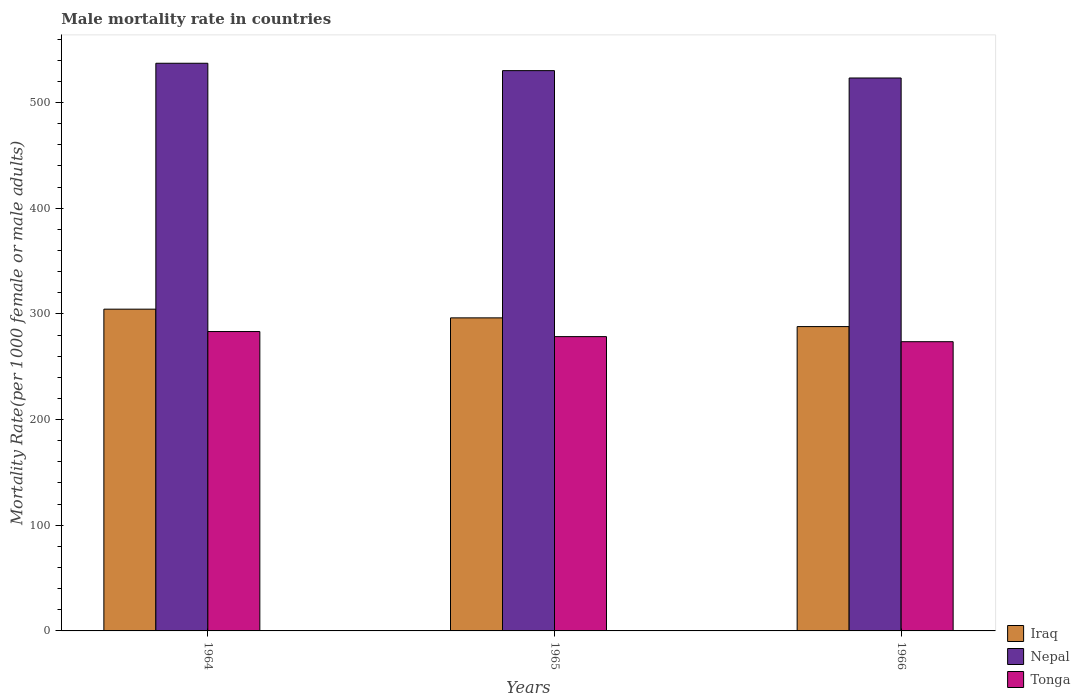How many bars are there on the 3rd tick from the left?
Make the answer very short. 3. What is the label of the 3rd group of bars from the left?
Keep it short and to the point. 1966. In how many cases, is the number of bars for a given year not equal to the number of legend labels?
Your answer should be very brief. 0. What is the male mortality rate in Tonga in 1964?
Offer a very short reply. 283.32. Across all years, what is the maximum male mortality rate in Nepal?
Offer a very short reply. 537.21. Across all years, what is the minimum male mortality rate in Nepal?
Offer a very short reply. 523.26. In which year was the male mortality rate in Tonga maximum?
Make the answer very short. 1964. In which year was the male mortality rate in Tonga minimum?
Make the answer very short. 1966. What is the total male mortality rate in Tonga in the graph?
Your answer should be very brief. 835.54. What is the difference between the male mortality rate in Nepal in 1965 and that in 1966?
Your response must be concise. 6.97. What is the difference between the male mortality rate in Iraq in 1965 and the male mortality rate in Nepal in 1964?
Offer a terse response. -240.95. What is the average male mortality rate in Tonga per year?
Make the answer very short. 278.51. In the year 1964, what is the difference between the male mortality rate in Nepal and male mortality rate in Iraq?
Provide a short and direct response. 232.71. In how many years, is the male mortality rate in Nepal greater than 20?
Provide a succinct answer. 3. What is the ratio of the male mortality rate in Tonga in 1965 to that in 1966?
Provide a succinct answer. 1.02. Is the male mortality rate in Nepal in 1964 less than that in 1965?
Make the answer very short. No. Is the difference between the male mortality rate in Nepal in 1964 and 1966 greater than the difference between the male mortality rate in Iraq in 1964 and 1966?
Provide a short and direct response. No. What is the difference between the highest and the second highest male mortality rate in Nepal?
Your response must be concise. 6.97. What is the difference between the highest and the lowest male mortality rate in Nepal?
Offer a terse response. 13.94. In how many years, is the male mortality rate in Tonga greater than the average male mortality rate in Tonga taken over all years?
Provide a succinct answer. 1. Is the sum of the male mortality rate in Tonga in 1964 and 1966 greater than the maximum male mortality rate in Iraq across all years?
Offer a very short reply. Yes. What does the 3rd bar from the left in 1966 represents?
Make the answer very short. Tonga. What does the 2nd bar from the right in 1966 represents?
Your answer should be compact. Nepal. Are the values on the major ticks of Y-axis written in scientific E-notation?
Keep it short and to the point. No. Does the graph contain any zero values?
Ensure brevity in your answer.  No. Where does the legend appear in the graph?
Your response must be concise. Bottom right. How many legend labels are there?
Your answer should be compact. 3. What is the title of the graph?
Give a very brief answer. Male mortality rate in countries. Does "Kazakhstan" appear as one of the legend labels in the graph?
Keep it short and to the point. No. What is the label or title of the Y-axis?
Your answer should be compact. Mortality Rate(per 1000 female or male adults). What is the Mortality Rate(per 1000 female or male adults) in Iraq in 1964?
Provide a succinct answer. 304.5. What is the Mortality Rate(per 1000 female or male adults) in Nepal in 1964?
Offer a very short reply. 537.21. What is the Mortality Rate(per 1000 female or male adults) of Tonga in 1964?
Make the answer very short. 283.32. What is the Mortality Rate(per 1000 female or male adults) of Iraq in 1965?
Offer a terse response. 296.25. What is the Mortality Rate(per 1000 female or male adults) in Nepal in 1965?
Your response must be concise. 530.23. What is the Mortality Rate(per 1000 female or male adults) in Tonga in 1965?
Give a very brief answer. 278.51. What is the Mortality Rate(per 1000 female or male adults) of Iraq in 1966?
Provide a succinct answer. 288.01. What is the Mortality Rate(per 1000 female or male adults) of Nepal in 1966?
Provide a short and direct response. 523.26. What is the Mortality Rate(per 1000 female or male adults) of Tonga in 1966?
Make the answer very short. 273.71. Across all years, what is the maximum Mortality Rate(per 1000 female or male adults) in Iraq?
Offer a terse response. 304.5. Across all years, what is the maximum Mortality Rate(per 1000 female or male adults) in Nepal?
Your answer should be compact. 537.21. Across all years, what is the maximum Mortality Rate(per 1000 female or male adults) in Tonga?
Make the answer very short. 283.32. Across all years, what is the minimum Mortality Rate(per 1000 female or male adults) of Iraq?
Ensure brevity in your answer.  288.01. Across all years, what is the minimum Mortality Rate(per 1000 female or male adults) of Nepal?
Your response must be concise. 523.26. Across all years, what is the minimum Mortality Rate(per 1000 female or male adults) in Tonga?
Your answer should be compact. 273.71. What is the total Mortality Rate(per 1000 female or male adults) in Iraq in the graph?
Make the answer very short. 888.76. What is the total Mortality Rate(per 1000 female or male adults) of Nepal in the graph?
Your answer should be very brief. 1590.7. What is the total Mortality Rate(per 1000 female or male adults) in Tonga in the graph?
Give a very brief answer. 835.54. What is the difference between the Mortality Rate(per 1000 female or male adults) in Iraq in 1964 and that in 1965?
Provide a succinct answer. 8.24. What is the difference between the Mortality Rate(per 1000 female or male adults) of Nepal in 1964 and that in 1965?
Your answer should be very brief. 6.97. What is the difference between the Mortality Rate(per 1000 female or male adults) of Tonga in 1964 and that in 1965?
Provide a short and direct response. 4.81. What is the difference between the Mortality Rate(per 1000 female or male adults) of Iraq in 1964 and that in 1966?
Your response must be concise. 16.48. What is the difference between the Mortality Rate(per 1000 female or male adults) in Nepal in 1964 and that in 1966?
Your answer should be very brief. 13.94. What is the difference between the Mortality Rate(per 1000 female or male adults) of Tonga in 1964 and that in 1966?
Provide a short and direct response. 9.62. What is the difference between the Mortality Rate(per 1000 female or male adults) of Iraq in 1965 and that in 1966?
Give a very brief answer. 8.24. What is the difference between the Mortality Rate(per 1000 female or male adults) in Nepal in 1965 and that in 1966?
Keep it short and to the point. 6.97. What is the difference between the Mortality Rate(per 1000 female or male adults) of Tonga in 1965 and that in 1966?
Offer a terse response. 4.81. What is the difference between the Mortality Rate(per 1000 female or male adults) in Iraq in 1964 and the Mortality Rate(per 1000 female or male adults) in Nepal in 1965?
Your answer should be compact. -225.74. What is the difference between the Mortality Rate(per 1000 female or male adults) of Iraq in 1964 and the Mortality Rate(per 1000 female or male adults) of Tonga in 1965?
Your answer should be very brief. 25.98. What is the difference between the Mortality Rate(per 1000 female or male adults) of Nepal in 1964 and the Mortality Rate(per 1000 female or male adults) of Tonga in 1965?
Give a very brief answer. 258.69. What is the difference between the Mortality Rate(per 1000 female or male adults) in Iraq in 1964 and the Mortality Rate(per 1000 female or male adults) in Nepal in 1966?
Your response must be concise. -218.76. What is the difference between the Mortality Rate(per 1000 female or male adults) of Iraq in 1964 and the Mortality Rate(per 1000 female or male adults) of Tonga in 1966?
Provide a short and direct response. 30.79. What is the difference between the Mortality Rate(per 1000 female or male adults) of Nepal in 1964 and the Mortality Rate(per 1000 female or male adults) of Tonga in 1966?
Ensure brevity in your answer.  263.5. What is the difference between the Mortality Rate(per 1000 female or male adults) of Iraq in 1965 and the Mortality Rate(per 1000 female or male adults) of Nepal in 1966?
Offer a very short reply. -227.01. What is the difference between the Mortality Rate(per 1000 female or male adults) in Iraq in 1965 and the Mortality Rate(per 1000 female or male adults) in Tonga in 1966?
Your answer should be compact. 22.55. What is the difference between the Mortality Rate(per 1000 female or male adults) of Nepal in 1965 and the Mortality Rate(per 1000 female or male adults) of Tonga in 1966?
Your answer should be compact. 256.53. What is the average Mortality Rate(per 1000 female or male adults) in Iraq per year?
Offer a terse response. 296.25. What is the average Mortality Rate(per 1000 female or male adults) of Nepal per year?
Your answer should be very brief. 530.23. What is the average Mortality Rate(per 1000 female or male adults) in Tonga per year?
Your answer should be compact. 278.51. In the year 1964, what is the difference between the Mortality Rate(per 1000 female or male adults) in Iraq and Mortality Rate(per 1000 female or male adults) in Nepal?
Your response must be concise. -232.71. In the year 1964, what is the difference between the Mortality Rate(per 1000 female or male adults) of Iraq and Mortality Rate(per 1000 female or male adults) of Tonga?
Make the answer very short. 21.17. In the year 1964, what is the difference between the Mortality Rate(per 1000 female or male adults) in Nepal and Mortality Rate(per 1000 female or male adults) in Tonga?
Your answer should be compact. 253.88. In the year 1965, what is the difference between the Mortality Rate(per 1000 female or male adults) of Iraq and Mortality Rate(per 1000 female or male adults) of Nepal?
Offer a terse response. -233.98. In the year 1965, what is the difference between the Mortality Rate(per 1000 female or male adults) of Iraq and Mortality Rate(per 1000 female or male adults) of Tonga?
Keep it short and to the point. 17.74. In the year 1965, what is the difference between the Mortality Rate(per 1000 female or male adults) of Nepal and Mortality Rate(per 1000 female or male adults) of Tonga?
Your response must be concise. 251.72. In the year 1966, what is the difference between the Mortality Rate(per 1000 female or male adults) in Iraq and Mortality Rate(per 1000 female or male adults) in Nepal?
Keep it short and to the point. -235.25. In the year 1966, what is the difference between the Mortality Rate(per 1000 female or male adults) of Iraq and Mortality Rate(per 1000 female or male adults) of Tonga?
Your answer should be very brief. 14.3. In the year 1966, what is the difference between the Mortality Rate(per 1000 female or male adults) in Nepal and Mortality Rate(per 1000 female or male adults) in Tonga?
Offer a very short reply. 249.55. What is the ratio of the Mortality Rate(per 1000 female or male adults) of Iraq in 1964 to that in 1965?
Give a very brief answer. 1.03. What is the ratio of the Mortality Rate(per 1000 female or male adults) in Nepal in 1964 to that in 1965?
Offer a terse response. 1.01. What is the ratio of the Mortality Rate(per 1000 female or male adults) in Tonga in 1964 to that in 1965?
Your answer should be compact. 1.02. What is the ratio of the Mortality Rate(per 1000 female or male adults) of Iraq in 1964 to that in 1966?
Make the answer very short. 1.06. What is the ratio of the Mortality Rate(per 1000 female or male adults) of Nepal in 1964 to that in 1966?
Make the answer very short. 1.03. What is the ratio of the Mortality Rate(per 1000 female or male adults) in Tonga in 1964 to that in 1966?
Provide a succinct answer. 1.04. What is the ratio of the Mortality Rate(per 1000 female or male adults) of Iraq in 1965 to that in 1966?
Your response must be concise. 1.03. What is the ratio of the Mortality Rate(per 1000 female or male adults) of Nepal in 1965 to that in 1966?
Provide a succinct answer. 1.01. What is the ratio of the Mortality Rate(per 1000 female or male adults) of Tonga in 1965 to that in 1966?
Your response must be concise. 1.02. What is the difference between the highest and the second highest Mortality Rate(per 1000 female or male adults) in Iraq?
Your response must be concise. 8.24. What is the difference between the highest and the second highest Mortality Rate(per 1000 female or male adults) in Nepal?
Your answer should be compact. 6.97. What is the difference between the highest and the second highest Mortality Rate(per 1000 female or male adults) in Tonga?
Offer a terse response. 4.81. What is the difference between the highest and the lowest Mortality Rate(per 1000 female or male adults) of Iraq?
Provide a short and direct response. 16.48. What is the difference between the highest and the lowest Mortality Rate(per 1000 female or male adults) in Nepal?
Make the answer very short. 13.94. What is the difference between the highest and the lowest Mortality Rate(per 1000 female or male adults) in Tonga?
Provide a succinct answer. 9.62. 